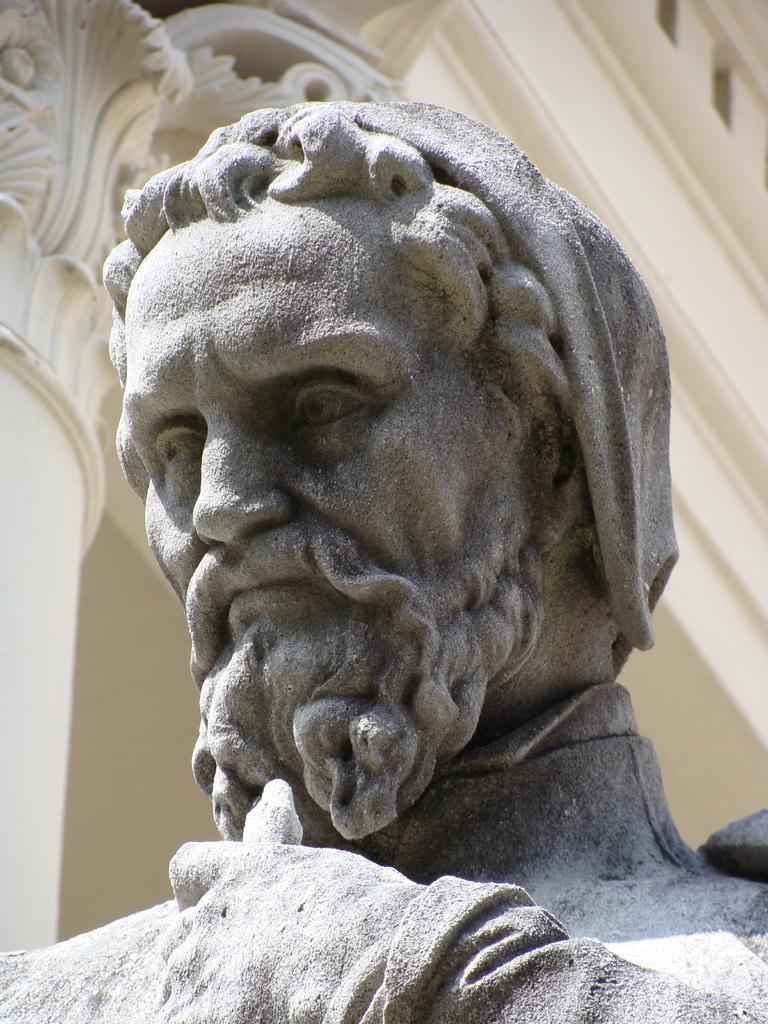In one or two sentences, can you explain what this image depicts? In this picture we can see a statue of a man and in the background we can see a building, pillar. 